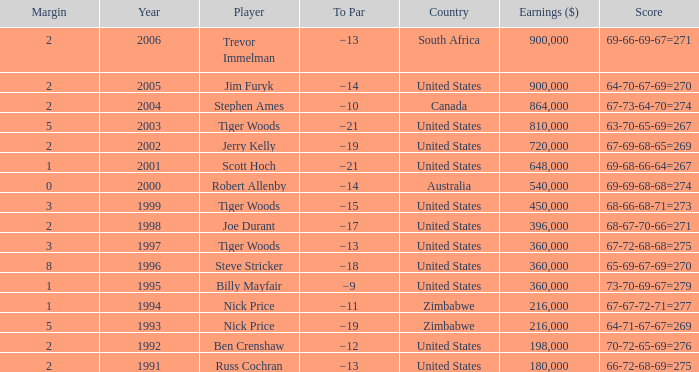What is russ cochran's average margin? 2.0. 